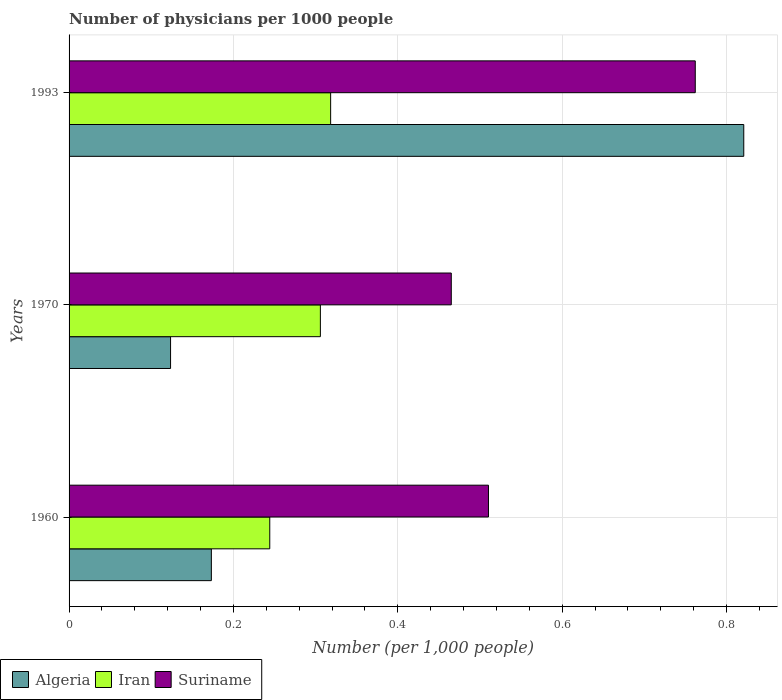How many different coloured bars are there?
Ensure brevity in your answer.  3. What is the number of physicians in Algeria in 1993?
Your answer should be compact. 0.82. Across all years, what is the maximum number of physicians in Algeria?
Your answer should be compact. 0.82. Across all years, what is the minimum number of physicians in Suriname?
Your answer should be compact. 0.47. In which year was the number of physicians in Suriname maximum?
Your response must be concise. 1993. In which year was the number of physicians in Iran minimum?
Your answer should be compact. 1960. What is the total number of physicians in Suriname in the graph?
Make the answer very short. 1.74. What is the difference between the number of physicians in Iran in 1960 and that in 1993?
Keep it short and to the point. -0.07. What is the difference between the number of physicians in Iran in 1993 and the number of physicians in Suriname in 1960?
Offer a terse response. -0.19. What is the average number of physicians in Algeria per year?
Your answer should be very brief. 0.37. In the year 1960, what is the difference between the number of physicians in Suriname and number of physicians in Iran?
Your answer should be very brief. 0.27. What is the ratio of the number of physicians in Suriname in 1970 to that in 1993?
Provide a succinct answer. 0.61. Is the difference between the number of physicians in Suriname in 1960 and 1993 greater than the difference between the number of physicians in Iran in 1960 and 1993?
Ensure brevity in your answer.  No. What is the difference between the highest and the second highest number of physicians in Suriname?
Keep it short and to the point. 0.25. What is the difference between the highest and the lowest number of physicians in Iran?
Your answer should be very brief. 0.07. In how many years, is the number of physicians in Algeria greater than the average number of physicians in Algeria taken over all years?
Provide a succinct answer. 1. What does the 3rd bar from the top in 1993 represents?
Make the answer very short. Algeria. What does the 3rd bar from the bottom in 1960 represents?
Ensure brevity in your answer.  Suriname. Is it the case that in every year, the sum of the number of physicians in Iran and number of physicians in Suriname is greater than the number of physicians in Algeria?
Your answer should be compact. Yes. How many bars are there?
Your answer should be very brief. 9. Are all the bars in the graph horizontal?
Make the answer very short. Yes. Does the graph contain any zero values?
Offer a terse response. No. How many legend labels are there?
Provide a short and direct response. 3. What is the title of the graph?
Offer a terse response. Number of physicians per 1000 people. Does "Chile" appear as one of the legend labels in the graph?
Ensure brevity in your answer.  No. What is the label or title of the X-axis?
Make the answer very short. Number (per 1,0 people). What is the label or title of the Y-axis?
Ensure brevity in your answer.  Years. What is the Number (per 1,000 people) of Algeria in 1960?
Offer a terse response. 0.17. What is the Number (per 1,000 people) in Iran in 1960?
Ensure brevity in your answer.  0.24. What is the Number (per 1,000 people) in Suriname in 1960?
Offer a terse response. 0.51. What is the Number (per 1,000 people) in Algeria in 1970?
Provide a succinct answer. 0.12. What is the Number (per 1,000 people) in Iran in 1970?
Keep it short and to the point. 0.31. What is the Number (per 1,000 people) of Suriname in 1970?
Provide a short and direct response. 0.47. What is the Number (per 1,000 people) of Algeria in 1993?
Make the answer very short. 0.82. What is the Number (per 1,000 people) of Iran in 1993?
Your response must be concise. 0.32. What is the Number (per 1,000 people) of Suriname in 1993?
Give a very brief answer. 0.76. Across all years, what is the maximum Number (per 1,000 people) of Algeria?
Give a very brief answer. 0.82. Across all years, what is the maximum Number (per 1,000 people) in Iran?
Offer a very short reply. 0.32. Across all years, what is the maximum Number (per 1,000 people) of Suriname?
Ensure brevity in your answer.  0.76. Across all years, what is the minimum Number (per 1,000 people) in Algeria?
Offer a terse response. 0.12. Across all years, what is the minimum Number (per 1,000 people) in Iran?
Keep it short and to the point. 0.24. Across all years, what is the minimum Number (per 1,000 people) in Suriname?
Offer a terse response. 0.47. What is the total Number (per 1,000 people) of Algeria in the graph?
Give a very brief answer. 1.12. What is the total Number (per 1,000 people) of Iran in the graph?
Offer a very short reply. 0.87. What is the total Number (per 1,000 people) of Suriname in the graph?
Make the answer very short. 1.74. What is the difference between the Number (per 1,000 people) in Algeria in 1960 and that in 1970?
Your answer should be very brief. 0.05. What is the difference between the Number (per 1,000 people) of Iran in 1960 and that in 1970?
Provide a succinct answer. -0.06. What is the difference between the Number (per 1,000 people) in Suriname in 1960 and that in 1970?
Your response must be concise. 0.05. What is the difference between the Number (per 1,000 people) in Algeria in 1960 and that in 1993?
Your answer should be very brief. -0.65. What is the difference between the Number (per 1,000 people) in Iran in 1960 and that in 1993?
Your answer should be very brief. -0.07. What is the difference between the Number (per 1,000 people) of Suriname in 1960 and that in 1993?
Ensure brevity in your answer.  -0.25. What is the difference between the Number (per 1,000 people) in Algeria in 1970 and that in 1993?
Your answer should be very brief. -0.7. What is the difference between the Number (per 1,000 people) of Iran in 1970 and that in 1993?
Provide a short and direct response. -0.01. What is the difference between the Number (per 1,000 people) of Suriname in 1970 and that in 1993?
Your answer should be very brief. -0.3. What is the difference between the Number (per 1,000 people) in Algeria in 1960 and the Number (per 1,000 people) in Iran in 1970?
Make the answer very short. -0.13. What is the difference between the Number (per 1,000 people) in Algeria in 1960 and the Number (per 1,000 people) in Suriname in 1970?
Your response must be concise. -0.29. What is the difference between the Number (per 1,000 people) of Iran in 1960 and the Number (per 1,000 people) of Suriname in 1970?
Give a very brief answer. -0.22. What is the difference between the Number (per 1,000 people) in Algeria in 1960 and the Number (per 1,000 people) in Iran in 1993?
Ensure brevity in your answer.  -0.15. What is the difference between the Number (per 1,000 people) of Algeria in 1960 and the Number (per 1,000 people) of Suriname in 1993?
Your answer should be very brief. -0.59. What is the difference between the Number (per 1,000 people) in Iran in 1960 and the Number (per 1,000 people) in Suriname in 1993?
Make the answer very short. -0.52. What is the difference between the Number (per 1,000 people) of Algeria in 1970 and the Number (per 1,000 people) of Iran in 1993?
Ensure brevity in your answer.  -0.19. What is the difference between the Number (per 1,000 people) of Algeria in 1970 and the Number (per 1,000 people) of Suriname in 1993?
Your answer should be compact. -0.64. What is the difference between the Number (per 1,000 people) in Iran in 1970 and the Number (per 1,000 people) in Suriname in 1993?
Give a very brief answer. -0.46. What is the average Number (per 1,000 people) of Algeria per year?
Make the answer very short. 0.37. What is the average Number (per 1,000 people) in Iran per year?
Keep it short and to the point. 0.29. What is the average Number (per 1,000 people) of Suriname per year?
Your answer should be compact. 0.58. In the year 1960, what is the difference between the Number (per 1,000 people) in Algeria and Number (per 1,000 people) in Iran?
Make the answer very short. -0.07. In the year 1960, what is the difference between the Number (per 1,000 people) of Algeria and Number (per 1,000 people) of Suriname?
Ensure brevity in your answer.  -0.34. In the year 1960, what is the difference between the Number (per 1,000 people) of Iran and Number (per 1,000 people) of Suriname?
Make the answer very short. -0.27. In the year 1970, what is the difference between the Number (per 1,000 people) in Algeria and Number (per 1,000 people) in Iran?
Give a very brief answer. -0.18. In the year 1970, what is the difference between the Number (per 1,000 people) in Algeria and Number (per 1,000 people) in Suriname?
Offer a terse response. -0.34. In the year 1970, what is the difference between the Number (per 1,000 people) in Iran and Number (per 1,000 people) in Suriname?
Offer a terse response. -0.16. In the year 1993, what is the difference between the Number (per 1,000 people) in Algeria and Number (per 1,000 people) in Iran?
Provide a succinct answer. 0.5. In the year 1993, what is the difference between the Number (per 1,000 people) of Algeria and Number (per 1,000 people) of Suriname?
Your answer should be compact. 0.06. In the year 1993, what is the difference between the Number (per 1,000 people) in Iran and Number (per 1,000 people) in Suriname?
Ensure brevity in your answer.  -0.44. What is the ratio of the Number (per 1,000 people) in Algeria in 1960 to that in 1970?
Your response must be concise. 1.4. What is the ratio of the Number (per 1,000 people) of Iran in 1960 to that in 1970?
Your answer should be very brief. 0.8. What is the ratio of the Number (per 1,000 people) of Suriname in 1960 to that in 1970?
Give a very brief answer. 1.1. What is the ratio of the Number (per 1,000 people) in Algeria in 1960 to that in 1993?
Your answer should be very brief. 0.21. What is the ratio of the Number (per 1,000 people) in Iran in 1960 to that in 1993?
Provide a succinct answer. 0.77. What is the ratio of the Number (per 1,000 people) of Suriname in 1960 to that in 1993?
Offer a very short reply. 0.67. What is the ratio of the Number (per 1,000 people) in Algeria in 1970 to that in 1993?
Make the answer very short. 0.15. What is the ratio of the Number (per 1,000 people) in Iran in 1970 to that in 1993?
Keep it short and to the point. 0.96. What is the ratio of the Number (per 1,000 people) in Suriname in 1970 to that in 1993?
Offer a terse response. 0.61. What is the difference between the highest and the second highest Number (per 1,000 people) of Algeria?
Your answer should be compact. 0.65. What is the difference between the highest and the second highest Number (per 1,000 people) in Iran?
Keep it short and to the point. 0.01. What is the difference between the highest and the second highest Number (per 1,000 people) of Suriname?
Keep it short and to the point. 0.25. What is the difference between the highest and the lowest Number (per 1,000 people) in Algeria?
Provide a succinct answer. 0.7. What is the difference between the highest and the lowest Number (per 1,000 people) in Iran?
Offer a terse response. 0.07. What is the difference between the highest and the lowest Number (per 1,000 people) of Suriname?
Provide a short and direct response. 0.3. 